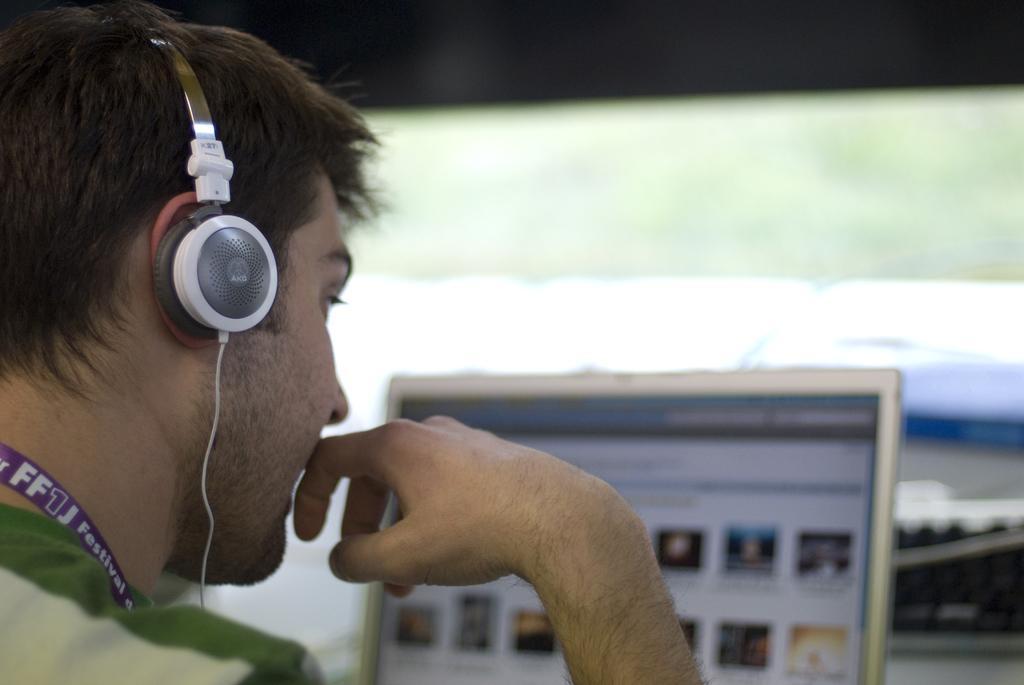Could you give a brief overview of what you see in this image? On the left side of the image a person is wearing a headset and sitting in-front of the laptop. 